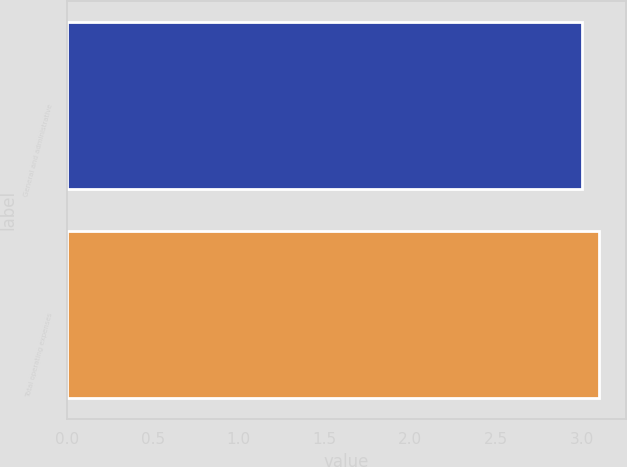<chart> <loc_0><loc_0><loc_500><loc_500><bar_chart><fcel>General and administrative<fcel>Total operating expenses<nl><fcel>3<fcel>3.1<nl></chart> 